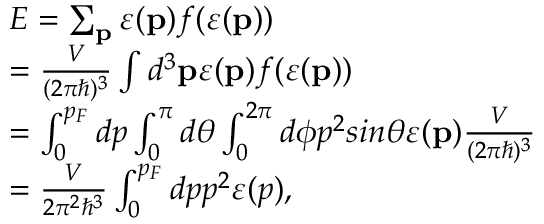Convert formula to latex. <formula><loc_0><loc_0><loc_500><loc_500>\begin{array} { l } { E = \sum _ { p } \varepsilon ( p ) f ( \varepsilon ( p ) ) } \\ { = \frac { V } { ( 2 \pi \hbar { ) } ^ { 3 } } \int d ^ { 3 } p \varepsilon ( p ) f ( \varepsilon ( p ) ) } \\ { = \int _ { 0 } ^ { p _ { F } } d p \int _ { 0 } ^ { \pi } d \theta \int _ { 0 } ^ { 2 \pi } d \phi p ^ { 2 } \sin \theta \varepsilon ( p ) \frac { V } { ( 2 \pi \hbar { ) } ^ { 3 } } } \\ { = \frac { V } { 2 \pi ^ { 2 } \hbar { ^ } { 3 } } \int _ { 0 } ^ { p _ { F } } d p p ^ { 2 } \varepsilon ( p ) , } \end{array}</formula> 